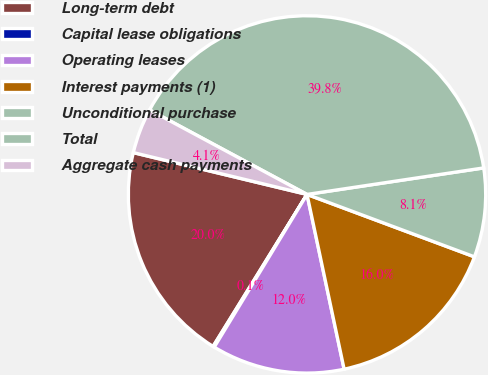Convert chart to OTSL. <chart><loc_0><loc_0><loc_500><loc_500><pie_chart><fcel>Long-term debt<fcel>Capital lease obligations<fcel>Operating leases<fcel>Interest payments (1)<fcel>Unconditional purchase<fcel>Total<fcel>Aggregate cash payments<nl><fcel>19.95%<fcel>0.12%<fcel>12.02%<fcel>15.99%<fcel>8.05%<fcel>39.79%<fcel>4.08%<nl></chart> 